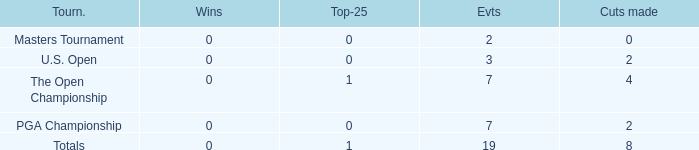What is the total number of cuts made of tournaments with 2 Events? 1.0. 